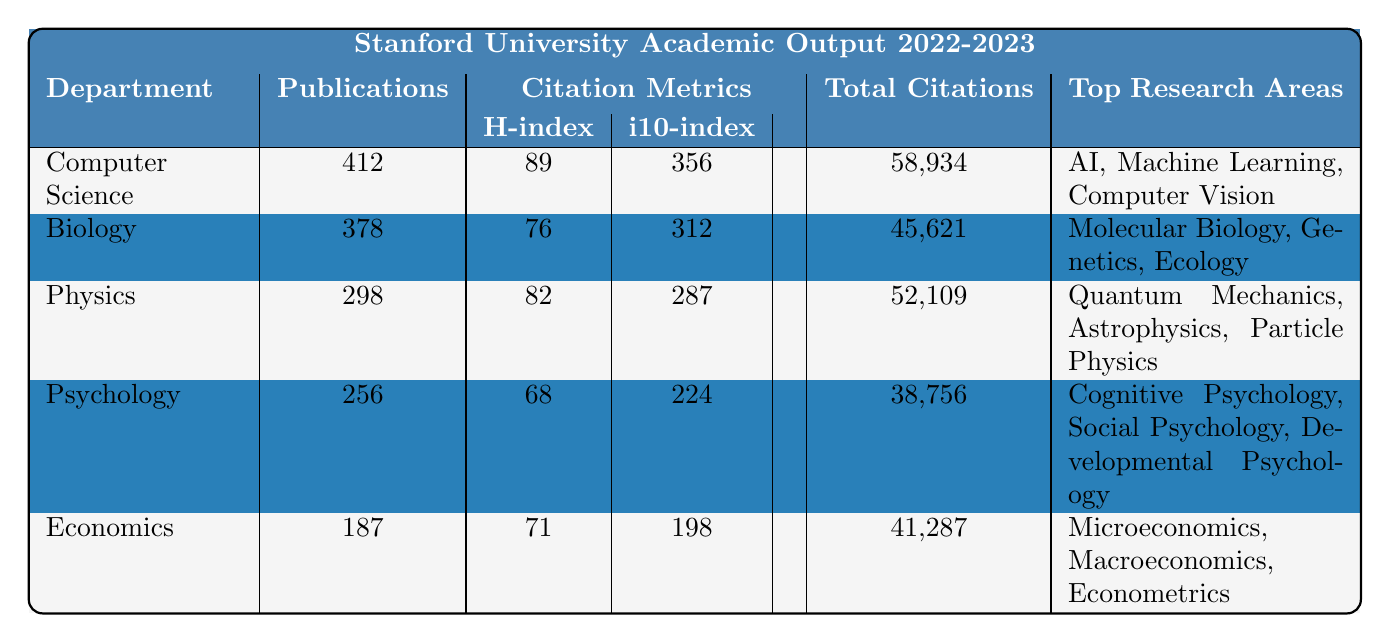What is the total number of publications in the Computer Science department? The table indicates that the Computer Science department has a publication output of 412.
Answer: 412 Which department has the highest H-index? The table shows that the H-index for the Computer Science department is 89, which is higher than the other departments listed.
Answer: Computer Science How many total citations does the Biology department have? According to the table, the Biology department has a total of 45,621 citations.
Answer: 45,621 What is the difference in publication outputs between the Physics and Economics departments? The Physics department has 298 publications and the Economics department has 187. The difference is 298 - 187 = 111.
Answer: 111 Identify the top research area for the Psychology department. The table lists the top research areas for the Psychology department as Cognitive Psychology, Social Psychology, and Developmental Psychology, indicating that its primary focus is on these areas.
Answer: Cognitive Psychology, Social Psychology, Developmental Psychology Is the i10-index of the Economics department greater than the i10-index of Psychology? The i10-index for Economics is 198 and for Psychology, it is 224. Since 198 is less than 224, the statement is false.
Answer: No What is the average number of total citations across all departments listed? To find the average, sum the total citations for all departments: 58,934 + 45,621 + 52,109 + 38,756 + 41,287 = 236,707. Then divide by 5 (the number of departments): 236,707 / 5 = 47,341.4.
Answer: 47,341.4 Which department has the least number of publications? By comparing the publication outputs, the Economics department with 187 publications has the least.
Answer: Economics If we combine the total citations of Computer Science and Physics, how many do we get? The total citations for Computer Science is 58,934 and for Physics is 52,109. Adding these gives 58,934 + 52,109 = 111,043.
Answer: 111,043 How many departments have an H-index above 75? The H-index values above 75 are 89 (Computer Science), 82 (Physics), and 76 (Biology), indicating that three departments have an H-index above this threshold.
Answer: 3 